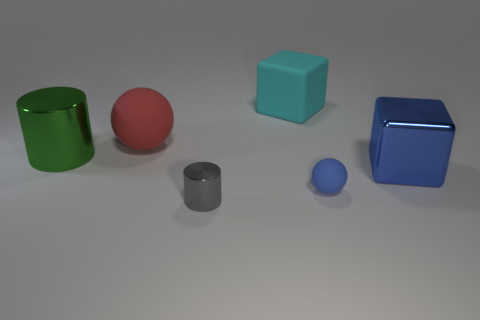How many objects are there and can you describe their shapes and colors? There are five objects in the image. Starting from the left, there's a green cylinder and a red sphere. Moving to the right, we see a teal cube, followed by a small gray cylinder and a small blue sphere. Each object has a uniformly colored surface with a glossy finish. 